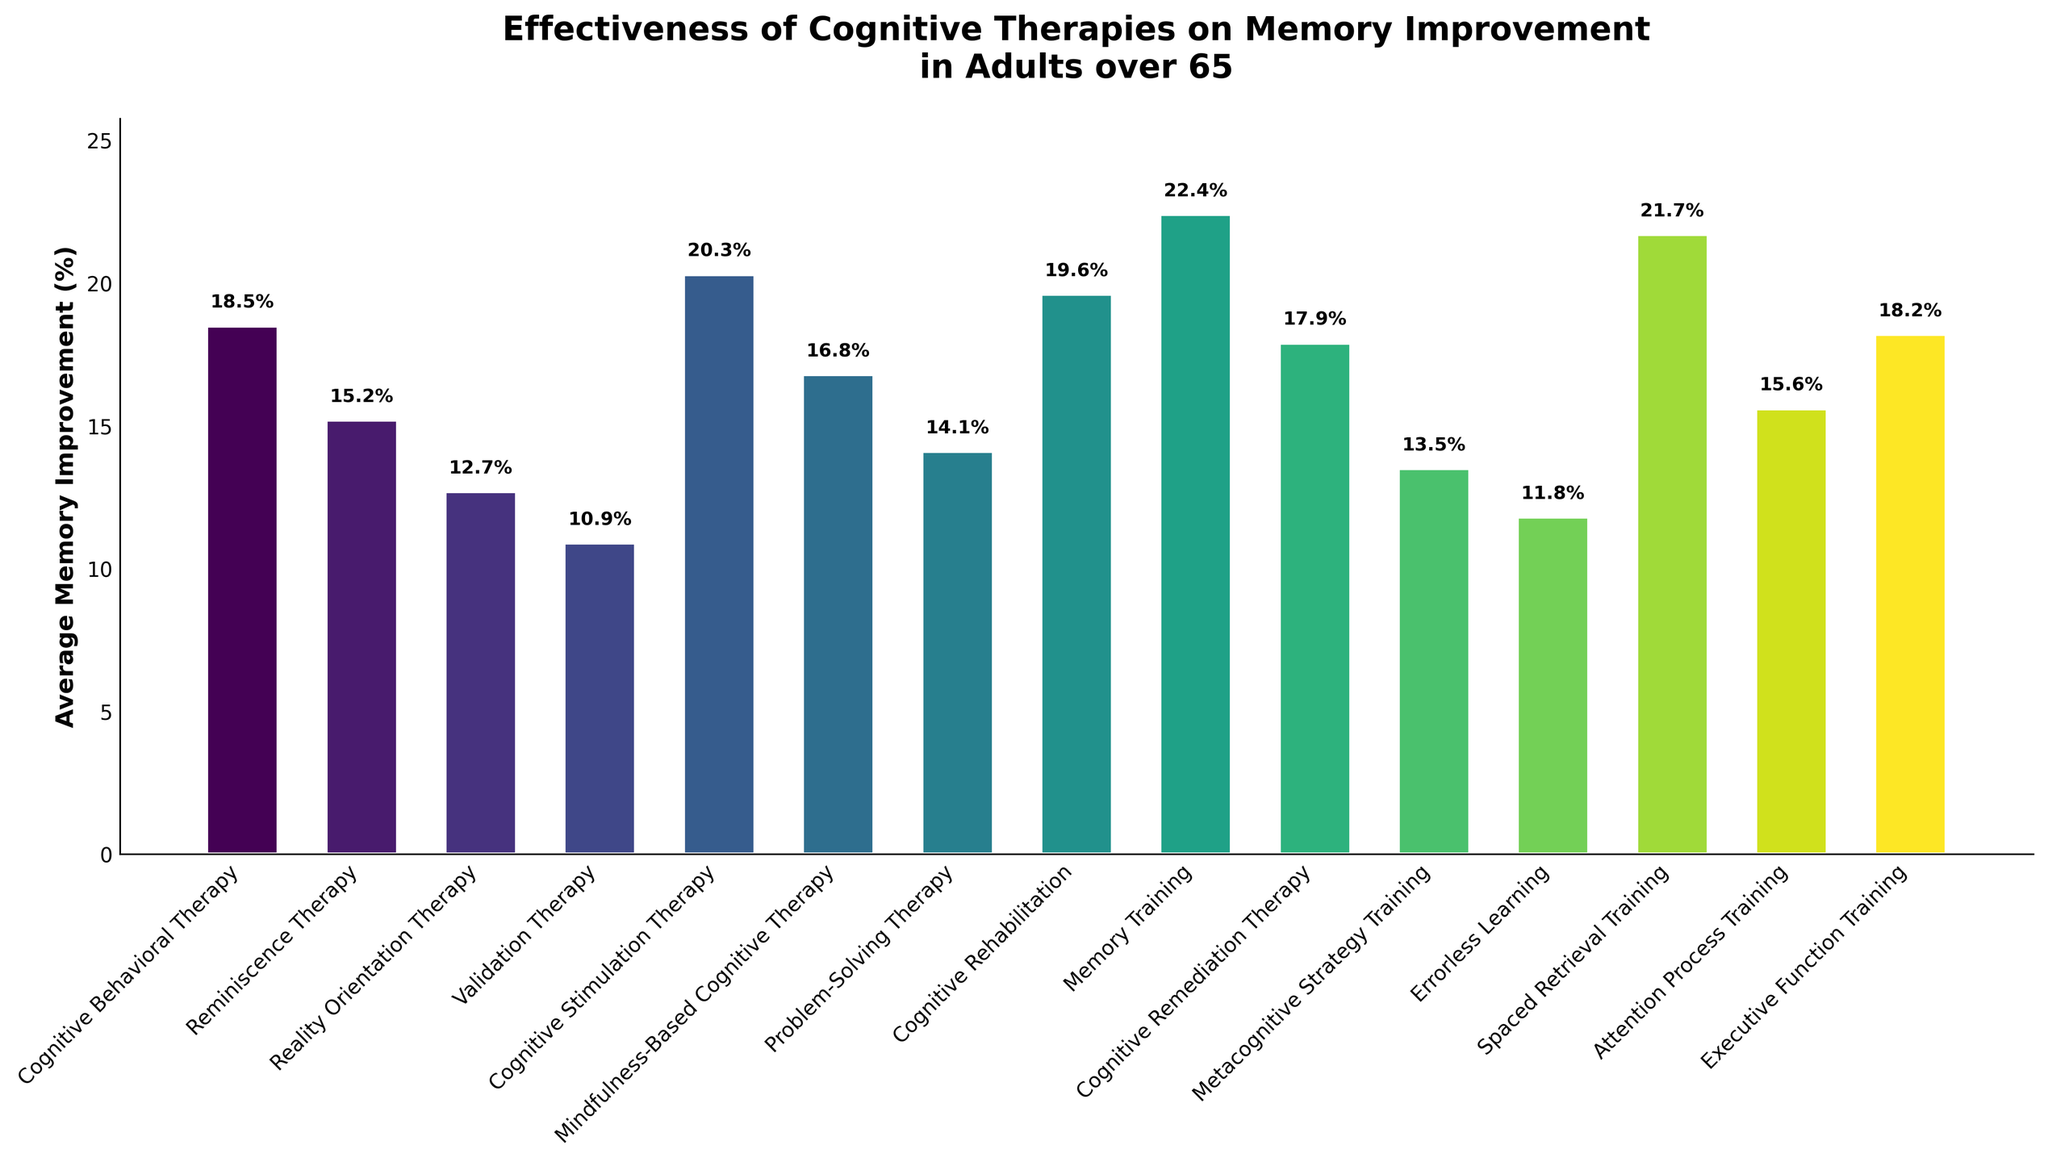Which therapy type shows the highest average memory improvement percentage? Look for the tallest bar on the chart, which represents the highest average memory improvement percentage.
Answer: Memory Training Which therapy has a higher average memory improvement percentage: Cognitive Behavioral Therapy or Executive Function Training? Compare the height of the bars for both Cognitive Behavioral Therapy and Executive Function Training.
Answer: Cognitive Behavioral Therapy What is the average memory improvement percentage shown for Validation Therapy? Find the bar labeled Validation Therapy and read its corresponding height on the y-axis.
Answer: 10.9% Does Spaced Retrieval Training improve memory more effectively than Reminiscence Therapy? Compare the height of the bars for Spaced Retrieval Training and Reminiscence Therapy.
Answer: Yes What is the sum of the average memory improvement percentages for the top three therapies? Identify the top three therapies with the highest bars and sum their average memory improvement percentages. E.g., Memory Training (22.4%), Spaced Retrieval Training (21.7%), Cognitive Stimulation Therapy (20.3%). 22.4 + 21.7 + 20.3 = 64.4
Answer: 64.4% Which therapy has the second-lowest average memory improvement percentage? Identify the second-lowest bar in terms of height and the corresponding therapy type.
Answer: Errorless Learning How many therapies have an average memory improvement percentage greater than 15%? Count the number of bars that are taller than the 15% mark on the y-axis.
Answer: 10 Compare the average memory improvement of Cognitive Behavioral Therapy with Mindfulness-Based Cognitive Therapy. Which is greater and by how much? Identify the bars for Cognitive Behavioral Therapy and Mindfulness-Based Cognitive Therapy, then subtract the smaller value from the larger one. 18.5% (CBT) - 16.8% (MBCT) = 1.7%
Answer: Cognitive Behavioral Therapy is greater by 1.7% Is the average memory improvement percentage of Problem-Solving Therapy closer to that of Reminiscence Therapy or Cognitive Remediation Therapy? Compare the numerical values of Problem-Solving Therapy to those of Reminiscence Therapy and Cognitive Remediation Therapy and see which difference is smaller. 14.1% (PST) - 15.2% (Reminiscence Therapy) = 1.1% and 17.9% - 14.1% = 3.8%. 1.1% < 3.8%
Answer: Reminiscence Therapy What is the difference in average memory improvement percentages between the therapy with the highest value and the therapy with the lowest value? Identify the bars with the highest and lowest values and subtract the smallest from the largest. 22.4% (Memory Training) - 10.9% (Validation Therapy) = 11.5%
Answer: 11.5% 